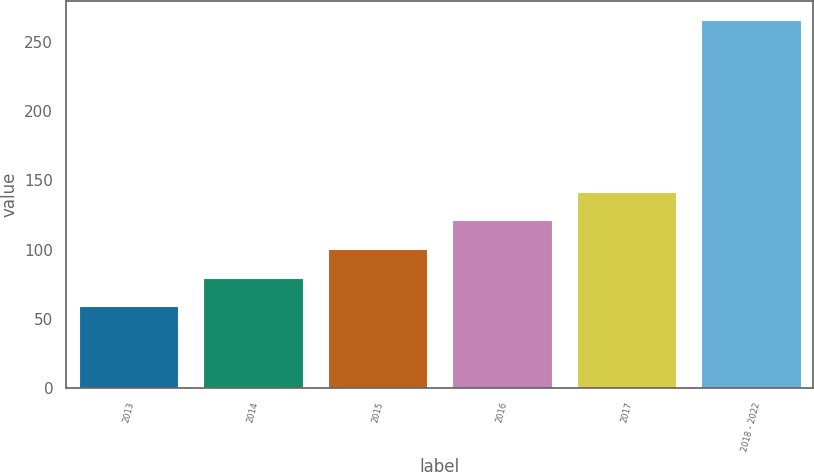Convert chart. <chart><loc_0><loc_0><loc_500><loc_500><bar_chart><fcel>2013<fcel>2014<fcel>2015<fcel>2016<fcel>2017<fcel>2018 - 2022<nl><fcel>59<fcel>79.7<fcel>100.4<fcel>121.1<fcel>141.8<fcel>266<nl></chart> 